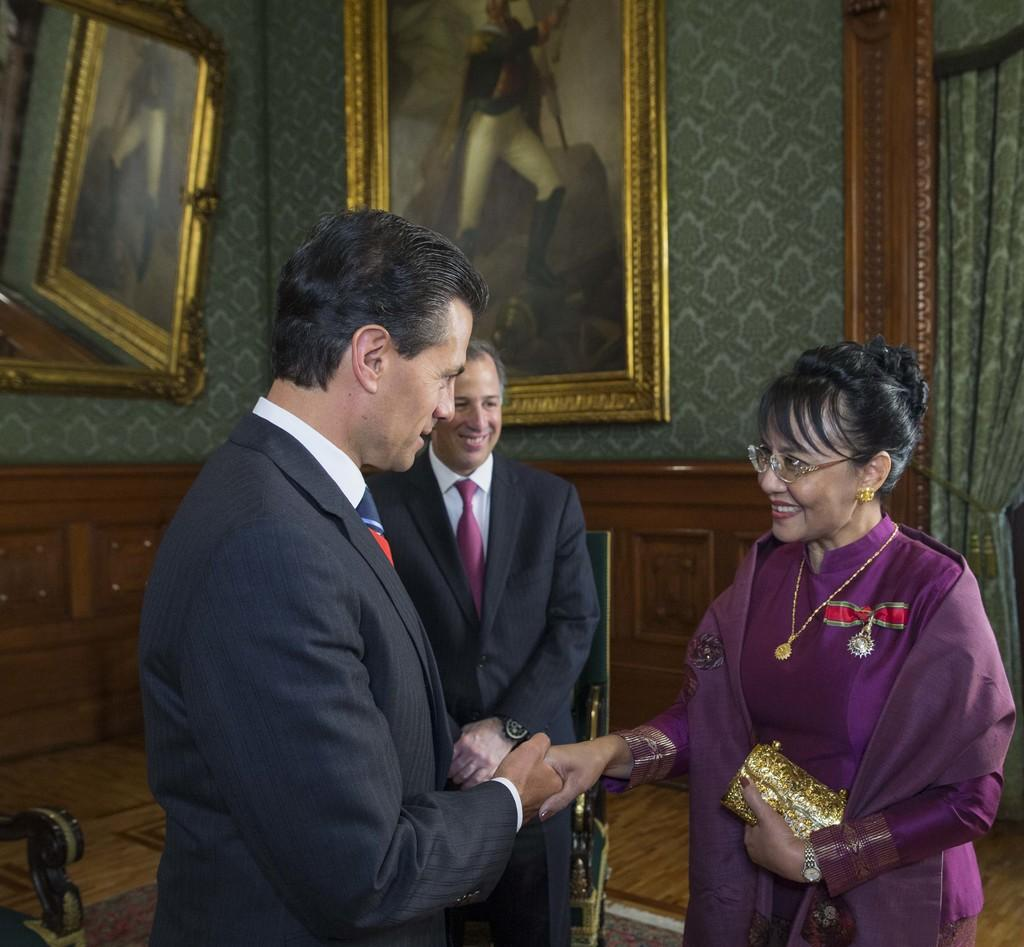How many people are visible in the front of the image? There are three people in the front of the image. What can be seen in the background of the image? There is a curtain and walls in the background of the image. What decorative elements are present on the walls? There is a mirror and a picture on the walls. What type of flooring is present in the image? The floor has a carpet. How many fish can be seen swimming in the carpet in the image? There are no fish visible in the image, and the carpet does not depict any fish. 